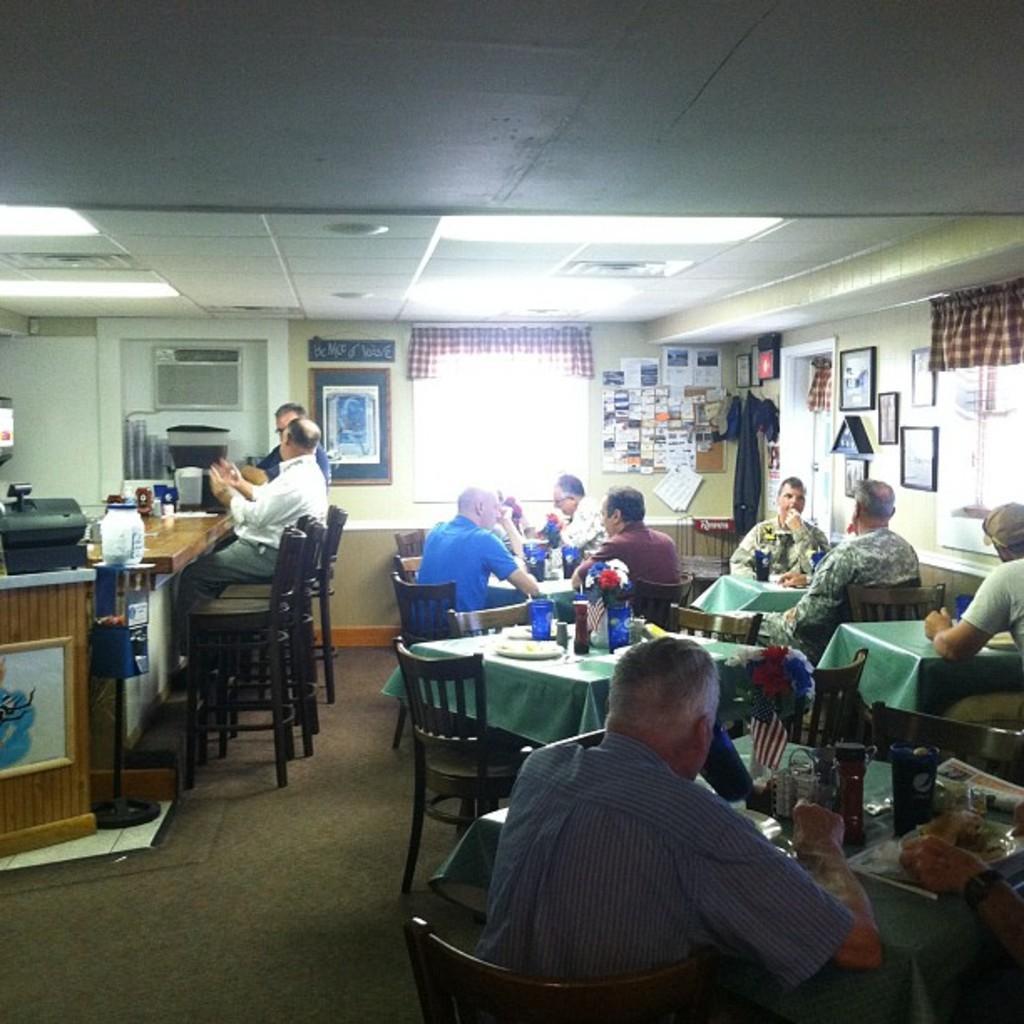Could you give a brief overview of what you see in this image? This image is taken inside a room. In this image there are few people sitting on the chairs. In the right side of the image a man is sitting on the chair and there is a table and on top of it there are many things. In the top of the image there is a ceiling with lights. at the background there is a wall with picture frames, window, curtains, posters with text on it and a hanger. At the bottom of the image there is a floor with mat. In this image everyone are sitting on the chairs. 